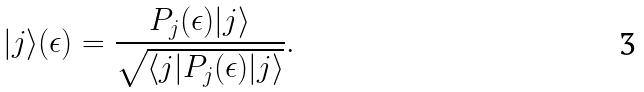<formula> <loc_0><loc_0><loc_500><loc_500>| j \rangle ( \epsilon ) = \frac { P _ { j } ( \epsilon ) | j \rangle } { \sqrt { \langle j | P _ { j } ( \epsilon ) | j \rangle } } .</formula> 